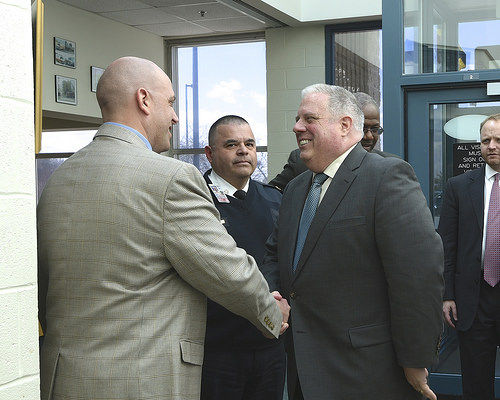<image>
Can you confirm if the picture is on the wall? Yes. Looking at the image, I can see the picture is positioned on top of the wall, with the wall providing support. 